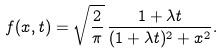Convert formula to latex. <formula><loc_0><loc_0><loc_500><loc_500>f ( x , t ) = \sqrt { \frac { 2 } { \pi } } \, { \frac { 1 + \lambda t } { ( 1 + \lambda t ) ^ { 2 } + x ^ { 2 } } } .</formula> 